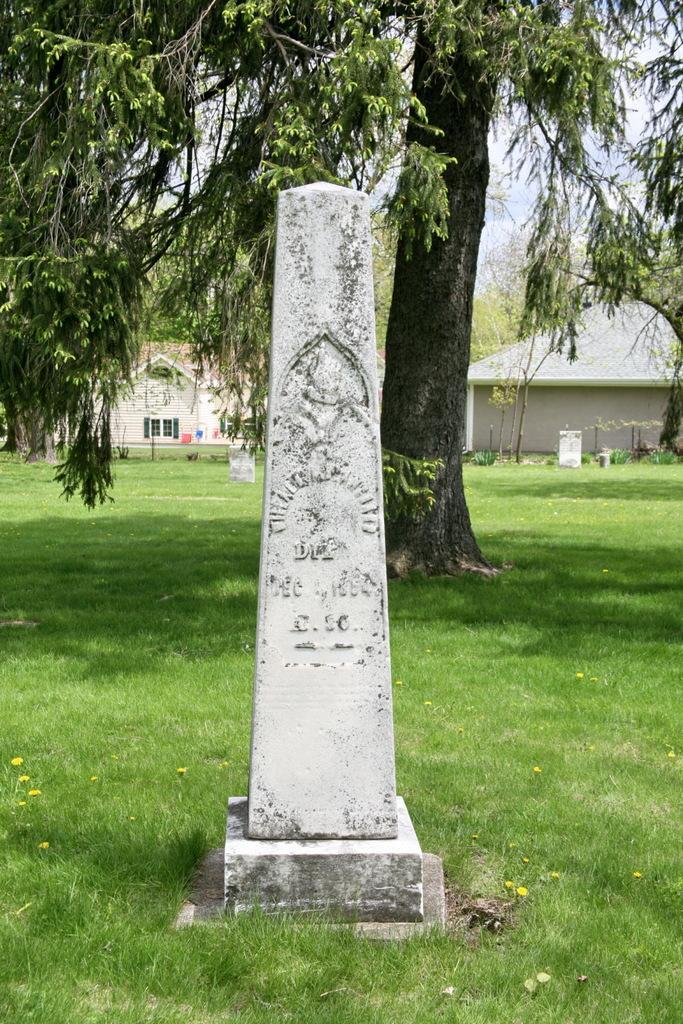How would you summarize this image in a sentence or two? This looks like a memorial stone. This is the grass. I can see a tree with branches and leaves. In the background, I think these are the houses with the windows. 